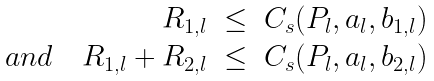Convert formula to latex. <formula><loc_0><loc_0><loc_500><loc_500>\begin{array} { r c l } R _ { 1 , l } & \leq & C _ { s } ( P _ { l } , a _ { l } , b _ { 1 , l } ) \\ a n d \quad R _ { 1 , l } + R _ { 2 , l } & \leq & C _ { s } ( P _ { l } , a _ { l } , b _ { 2 , l } ) \end{array}</formula> 